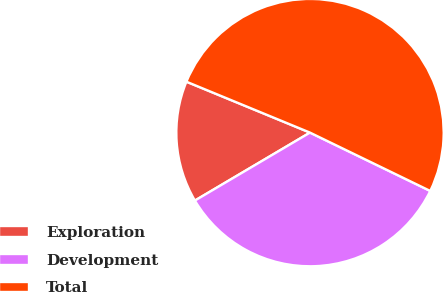Convert chart to OTSL. <chart><loc_0><loc_0><loc_500><loc_500><pie_chart><fcel>Exploration<fcel>Development<fcel>Total<nl><fcel>14.71%<fcel>34.32%<fcel>50.97%<nl></chart> 